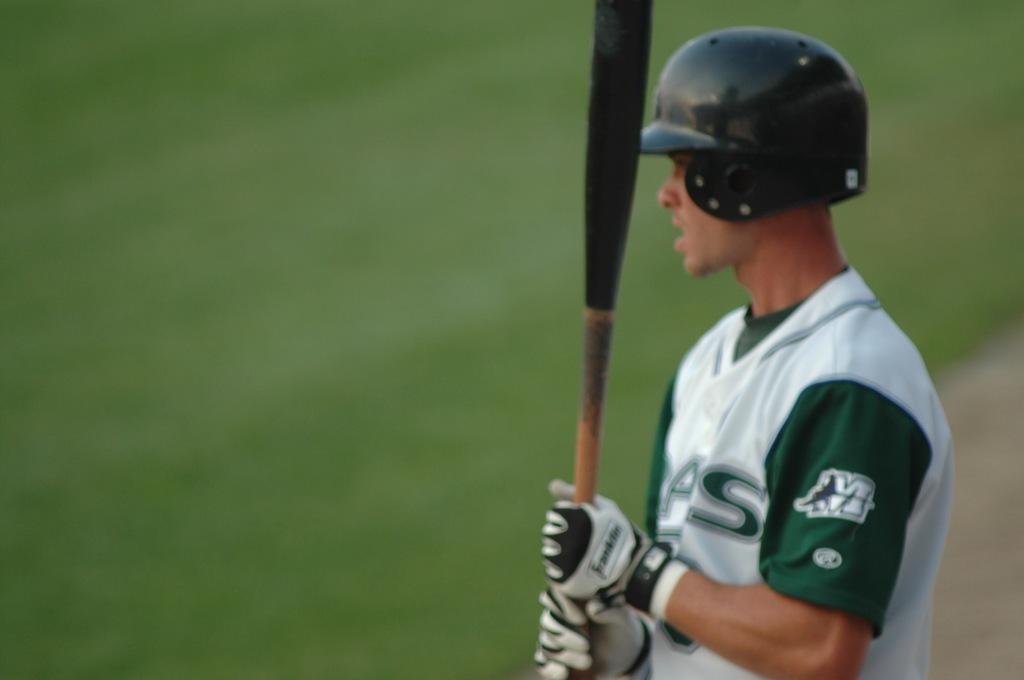Can you describe this image briefly? In this image there is a man he is wearing, black color helmet, white and green color T-shirt holding a bat in his hands. 